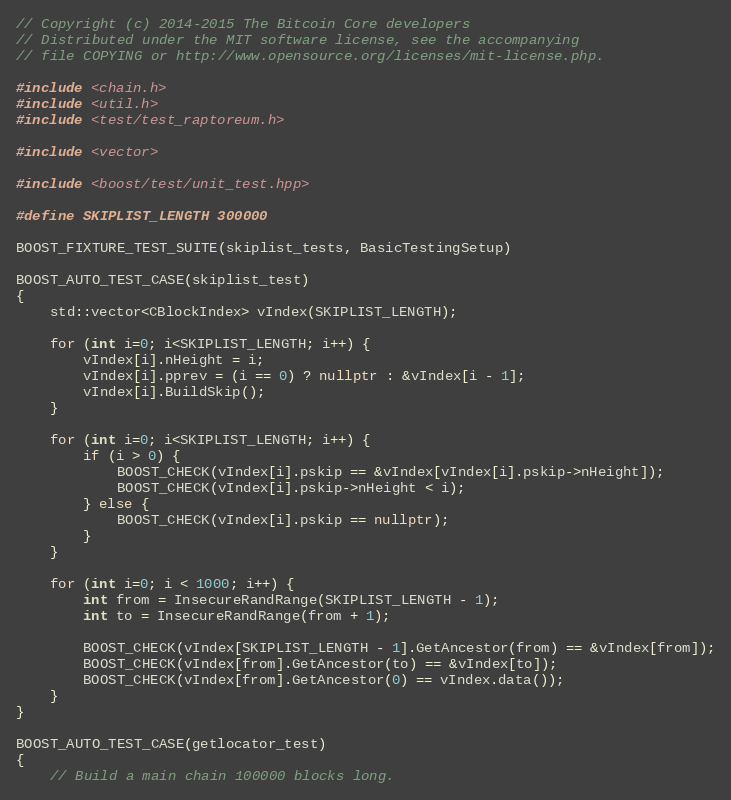<code> <loc_0><loc_0><loc_500><loc_500><_C++_>// Copyright (c) 2014-2015 The Bitcoin Core developers
// Distributed under the MIT software license, see the accompanying
// file COPYING or http://www.opensource.org/licenses/mit-license.php.

#include <chain.h>
#include <util.h>
#include <test/test_raptoreum.h>

#include <vector>

#include <boost/test/unit_test.hpp>

#define SKIPLIST_LENGTH 300000

BOOST_FIXTURE_TEST_SUITE(skiplist_tests, BasicTestingSetup)

BOOST_AUTO_TEST_CASE(skiplist_test)
{
    std::vector<CBlockIndex> vIndex(SKIPLIST_LENGTH);

    for (int i=0; i<SKIPLIST_LENGTH; i++) {
        vIndex[i].nHeight = i;
        vIndex[i].pprev = (i == 0) ? nullptr : &vIndex[i - 1];
        vIndex[i].BuildSkip();
    }

    for (int i=0; i<SKIPLIST_LENGTH; i++) {
        if (i > 0) {
            BOOST_CHECK(vIndex[i].pskip == &vIndex[vIndex[i].pskip->nHeight]);
            BOOST_CHECK(vIndex[i].pskip->nHeight < i);
        } else {
            BOOST_CHECK(vIndex[i].pskip == nullptr);
        }
    }

    for (int i=0; i < 1000; i++) {
        int from = InsecureRandRange(SKIPLIST_LENGTH - 1);
        int to = InsecureRandRange(from + 1);

        BOOST_CHECK(vIndex[SKIPLIST_LENGTH - 1].GetAncestor(from) == &vIndex[from]);
        BOOST_CHECK(vIndex[from].GetAncestor(to) == &vIndex[to]);
        BOOST_CHECK(vIndex[from].GetAncestor(0) == vIndex.data());
    }
}

BOOST_AUTO_TEST_CASE(getlocator_test)
{
    // Build a main chain 100000 blocks long.</code> 